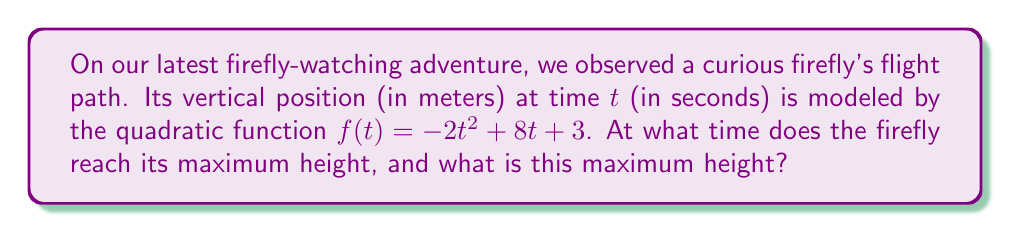Give your solution to this math problem. Let's approach this step-by-step:

1) The quadratic function is in the form $f(t) = -2t^2 + 8t + 3$, where $a = -2$, $b = 8$, and $c = 3$.

2) For a quadratic function $f(t) = at^2 + bt + c$, the vertex form is:
   $f(t) = a(t - h)^2 + k$
   where $(h, k)$ is the vertex of the parabola.

3) The t-coordinate of the vertex (which represents the time at maximum height) is given by:
   $h = -\frac{b}{2a}$

4) Substituting our values:
   $h = -\frac{8}{2(-2)} = -\frac{8}{-4} = 2$

5) So, the firefly reaches its maximum height at $t = 2$ seconds.

6) To find the maximum height, we substitute $t = 2$ into our original function:
   $f(2) = -2(2)^2 + 8(2) + 3$
   $    = -2(4) + 16 + 3$
   $    = -8 + 16 + 3$
   $    = 11$

Therefore, the maximum height is 11 meters.
Answer: Time: 2 seconds; Maximum height: 11 meters 